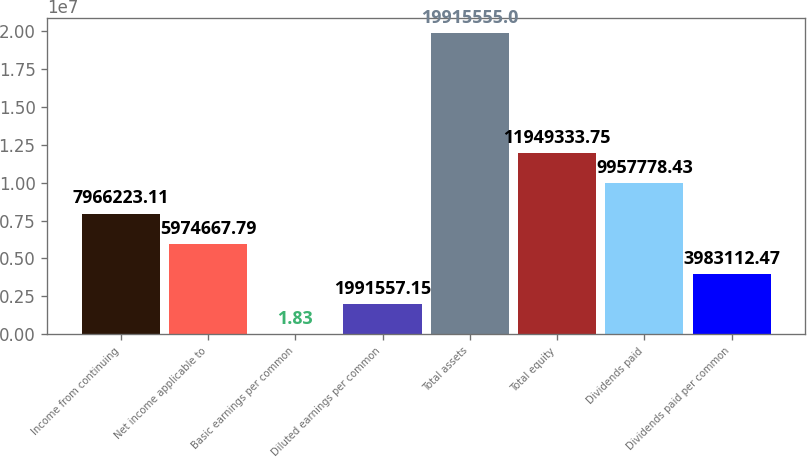Convert chart to OTSL. <chart><loc_0><loc_0><loc_500><loc_500><bar_chart><fcel>Income from continuing<fcel>Net income applicable to<fcel>Basic earnings per common<fcel>Diluted earnings per common<fcel>Total assets<fcel>Total equity<fcel>Dividends paid<fcel>Dividends paid per common<nl><fcel>7.96622e+06<fcel>5.97467e+06<fcel>1.83<fcel>1.99156e+06<fcel>1.99156e+07<fcel>1.19493e+07<fcel>9.95778e+06<fcel>3.98311e+06<nl></chart> 